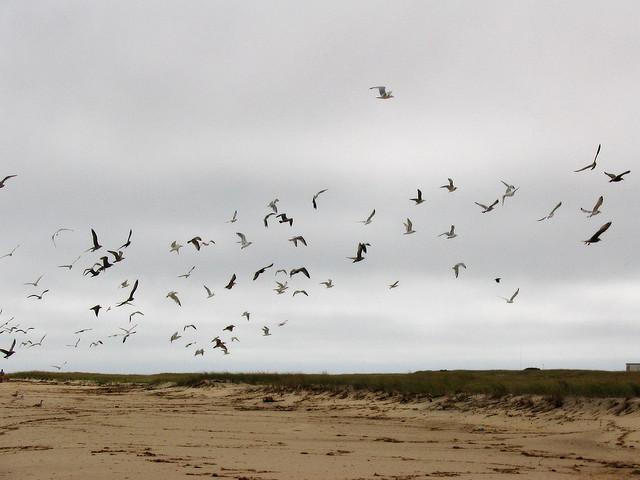What are the black specks?
Keep it brief. Birds. Are there lines in the dirt?
Keep it brief. Yes. Are there any seagulls in the air?
Short answer required. Yes. What are the birds doing?
Be succinct. Flying. What is the object in the sky?
Be succinct. Birds. Has anyone else been on this beach today?
Short answer required. Yes. How many animals are pictured?
Quick response, please. 20. What similarity does the left half of the picture have to the right side?
Concise answer only. Birds. How many birds are on the ground?
Be succinct. 0. What activity is happening on the beach?
Give a very brief answer. Birds flying. Is it snowing?
Write a very short answer. No. Is more sand than grass visible?
Answer briefly. Yes. Does this look like a very large beach?
Give a very brief answer. Yes. What is in the sky?
Be succinct. Birds. How many birds are in this picture?
Concise answer only. Many. What are there several of in the sky?
Concise answer only. Birds. Where are the birds headed?
Write a very short answer. South. Is it foggy?
Give a very brief answer. No. What kind of birds are these?
Short answer required. Seagulls. Are these birds fighting?
Keep it brief. No. 